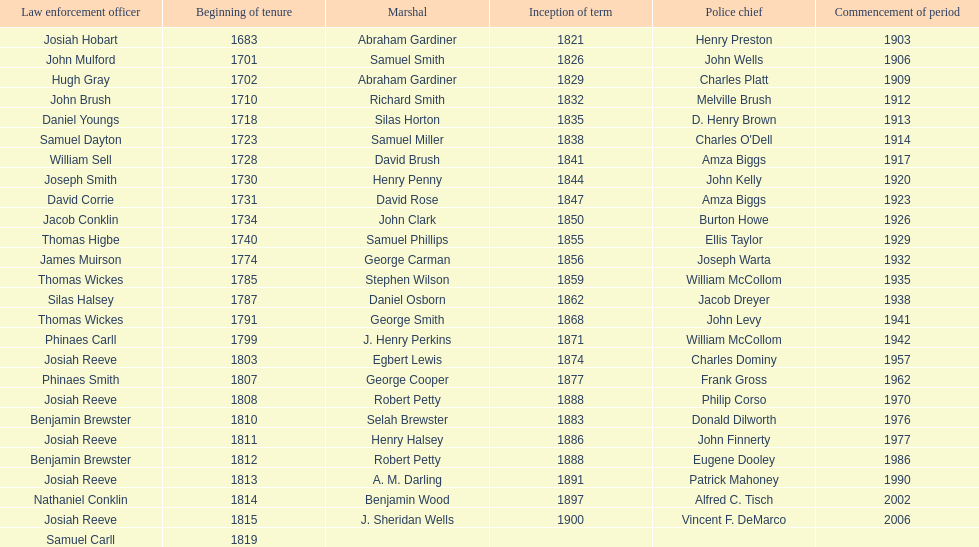When did benjamin brewster serve his second term? 1812. 